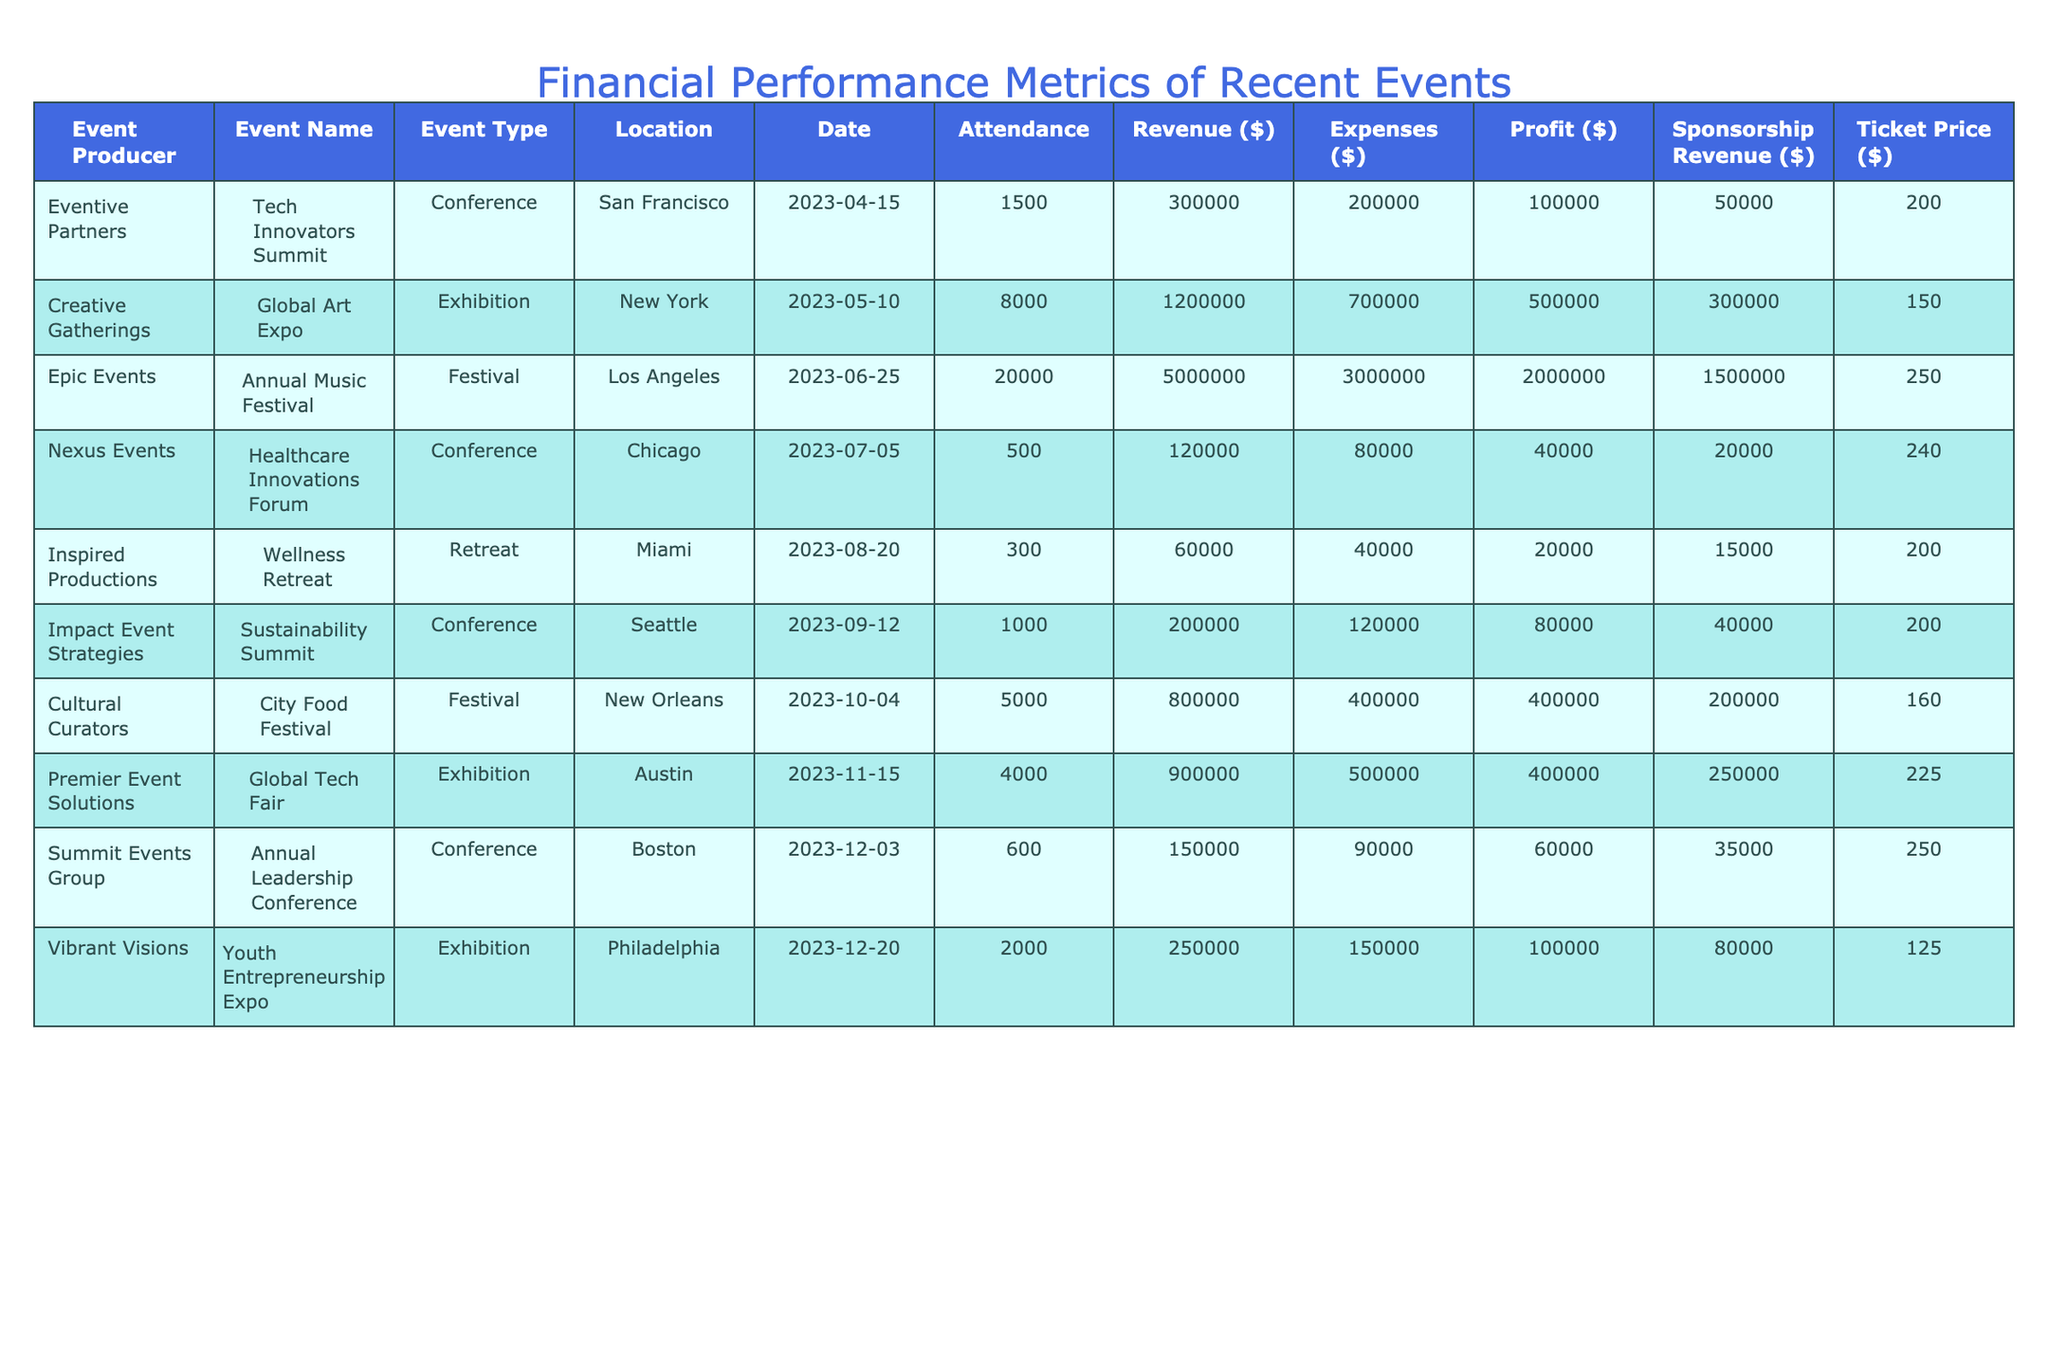What is the total revenue from all the events in the table? To find the total revenue, we add up the revenue from each event. The revenues are 300000, 1200000, 5000000, 120000, 60000, 200000, 800000, 900000, and 250000. Adding these gives us 300000 + 1200000 + 5000000 + 120000 + 60000 + 200000 + 800000 + 900000 + 250000 = 8470000.
Answer: 8470000 Which event had the highest profit? By examining the profit column, we see the profits: 100000, 500000, 2000000, 40000, 20000, 80000, 400000, 400000, and 100000. The highest profit is 2000000 from the Annual Music Festival.
Answer: Annual Music Festival Did the Global Art Expo generate more sponsorship revenue than the Tech Innovators Summit? The sponsorship revenue for the Global Art Expo is 300000, while for the Tech Innovators Summit it is 50000. Since 300000 is greater than 50000, the statement is true.
Answer: Yes What was the average ticket price for the events listed? To find the average ticket price, we sum the ticket prices: 200, 150, 250, 240, 200, 200, 160, 225, 125. This gives us a sum of 1840. There are 9 events, so the average ticket price is 1840/9 ≈ 204.44.
Answer: 204.44 Is it true that every event listed in the table had more attendees than 1000? We look for any events with an attendance of 1000 or less. The Wellness Retreat had only 300 attendees, which means not all events had more than 1000 attendees.
Answer: No What is the total profit from the exhibitions? We need to identify the events categorized as exhibitions. These are the Global Art Expo, Premier Event Solutions, and Youth Entrepreneurship Expo with profits 500000, 400000, and 100000 respectively. Summing these profits gives us 500000 + 400000 + 100000 = 1000000.
Answer: 1000000 Which city hosted the event with the lowest attendance? The event with the lowest attendance is the Wellness Retreat with 300 attendees located in Miami. Therefore, the city is Miami.
Answer: Miami How much more did the Annual Music Festival earn in revenue compared to expenses? To find this, we take the revenue of the Annual Music Festival (5000000) and subtract its expenses (3000000). Thus, the difference is 5000000 - 3000000 = 2000000.
Answer: 2000000 What percentage of the total revenue was generated from sponsorships at the City Food Festival? The sponsorship revenue from the City Food Festival is 200000, and the total revenue is 800000. To find the percentage, we divide sponsorship revenue by total revenue: (200000 / 800000) * 100 = 25%.
Answer: 25% 